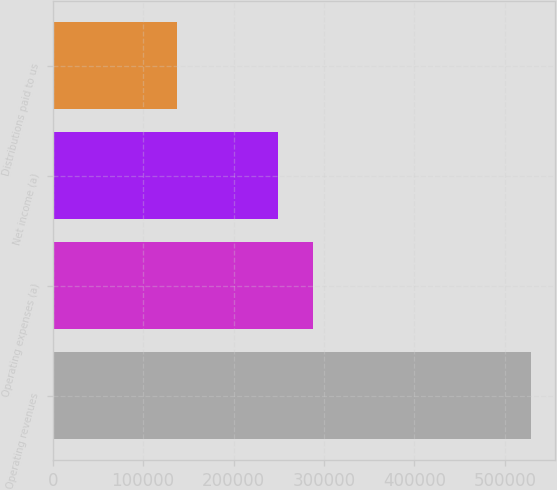Convert chart. <chart><loc_0><loc_0><loc_500><loc_500><bar_chart><fcel>Operating revenues<fcel>Operating expenses (a)<fcel>Net income (a)<fcel>Distributions paid to us<nl><fcel>528665<fcel>288115<fcel>248998<fcel>137498<nl></chart> 